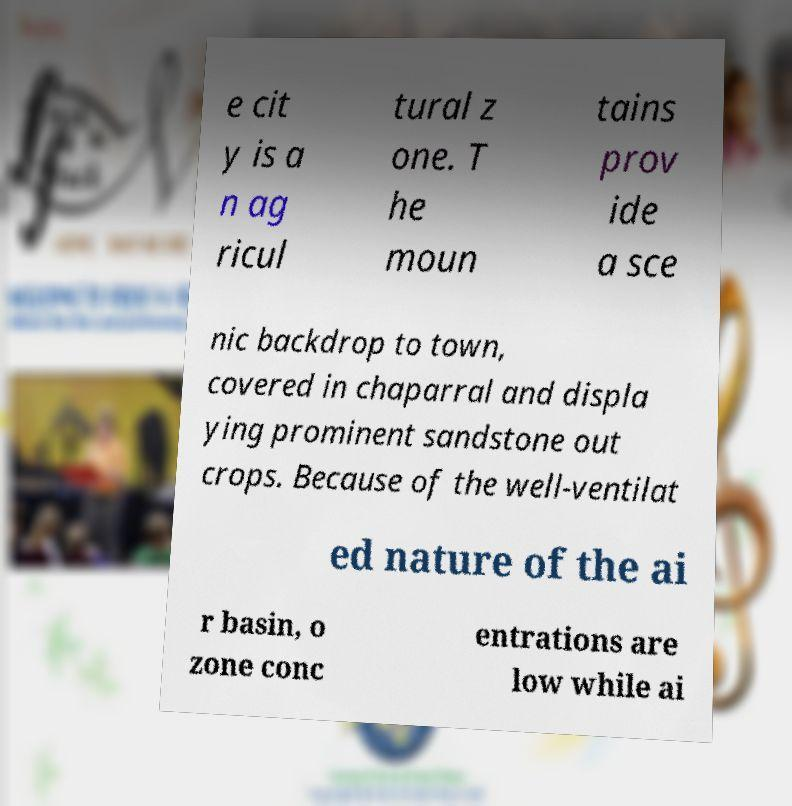Can you accurately transcribe the text from the provided image for me? e cit y is a n ag ricul tural z one. T he moun tains prov ide a sce nic backdrop to town, covered in chaparral and displa ying prominent sandstone out crops. Because of the well-ventilat ed nature of the ai r basin, o zone conc entrations are low while ai 